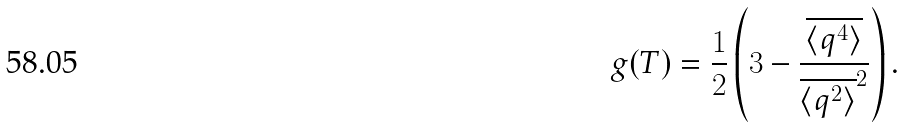<formula> <loc_0><loc_0><loc_500><loc_500>g ( T ) = \frac { 1 } { 2 } \left ( 3 - \frac { \overline { \langle q ^ { 4 } \rangle } } { \overline { \langle q ^ { 2 } \rangle } ^ { 2 } } \right ) .</formula> 